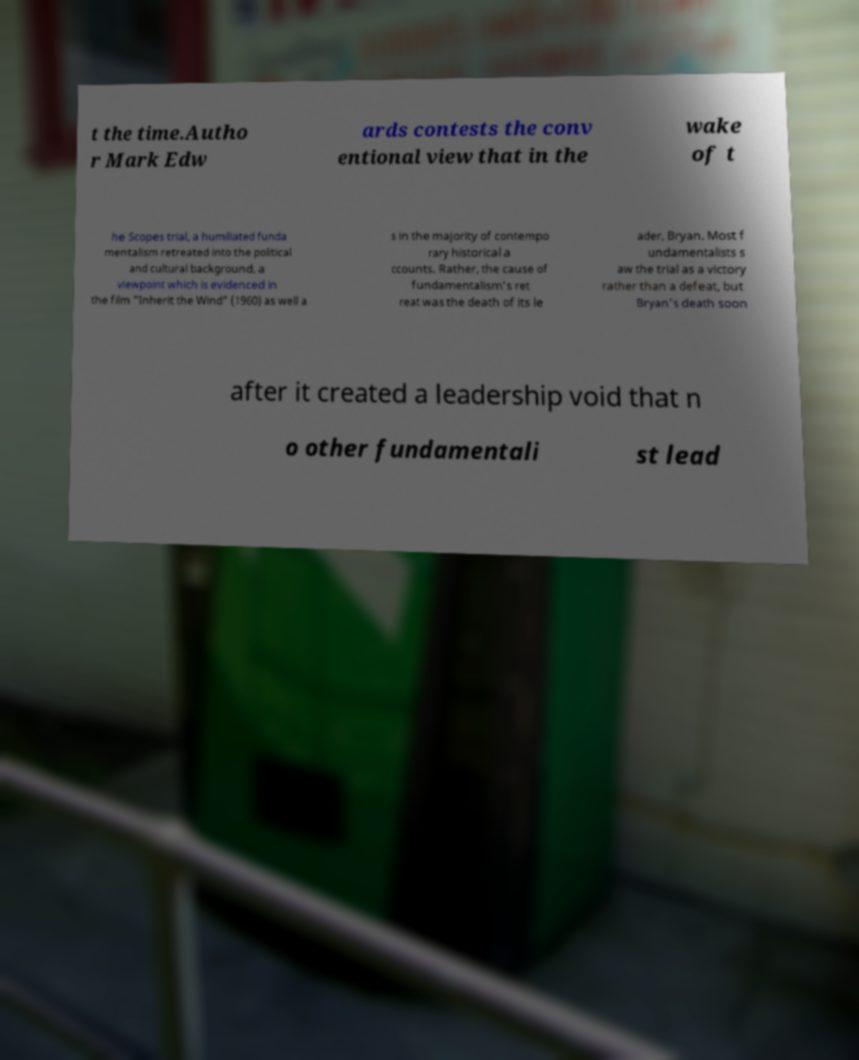Could you assist in decoding the text presented in this image and type it out clearly? t the time.Autho r Mark Edw ards contests the conv entional view that in the wake of t he Scopes trial, a humiliated funda mentalism retreated into the political and cultural background, a viewpoint which is evidenced in the film "Inherit the Wind" (1960) as well a s in the majority of contempo rary historical a ccounts. Rather, the cause of fundamentalism's ret reat was the death of its le ader, Bryan. Most f undamentalists s aw the trial as a victory rather than a defeat, but Bryan's death soon after it created a leadership void that n o other fundamentali st lead 